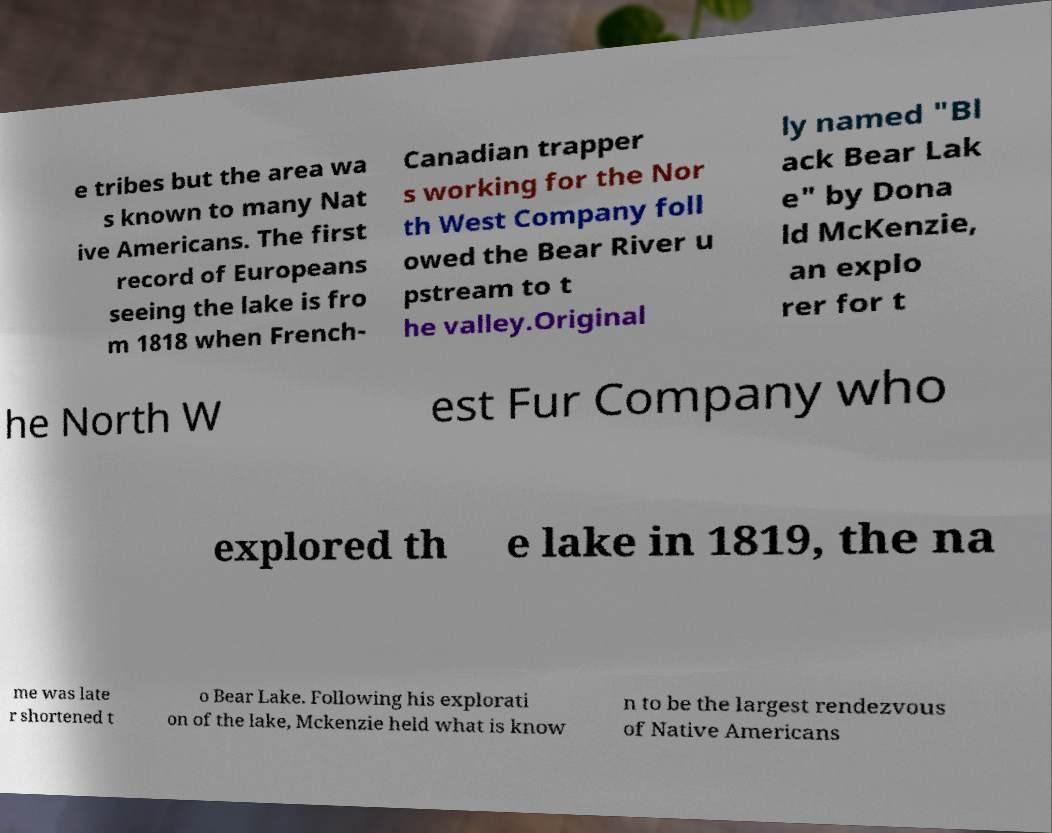I need the written content from this picture converted into text. Can you do that? e tribes but the area wa s known to many Nat ive Americans. The first record of Europeans seeing the lake is fro m 1818 when French- Canadian trapper s working for the Nor th West Company foll owed the Bear River u pstream to t he valley.Original ly named "Bl ack Bear Lak e" by Dona ld McKenzie, an explo rer for t he North W est Fur Company who explored th e lake in 1819, the na me was late r shortened t o Bear Lake. Following his explorati on of the lake, Mckenzie held what is know n to be the largest rendezvous of Native Americans 